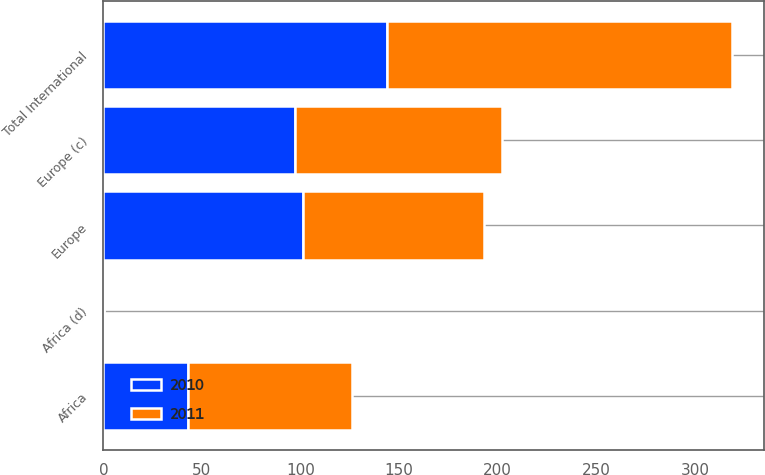Convert chart to OTSL. <chart><loc_0><loc_0><loc_500><loc_500><stacked_bar_chart><ecel><fcel>Europe<fcel>Africa<fcel>Total International<fcel>Europe (c)<fcel>Africa (d)<nl><fcel>2010<fcel>101<fcel>43<fcel>144<fcel>97<fcel>0.24<nl><fcel>2011<fcel>92<fcel>83<fcel>175<fcel>105<fcel>0.25<nl></chart> 